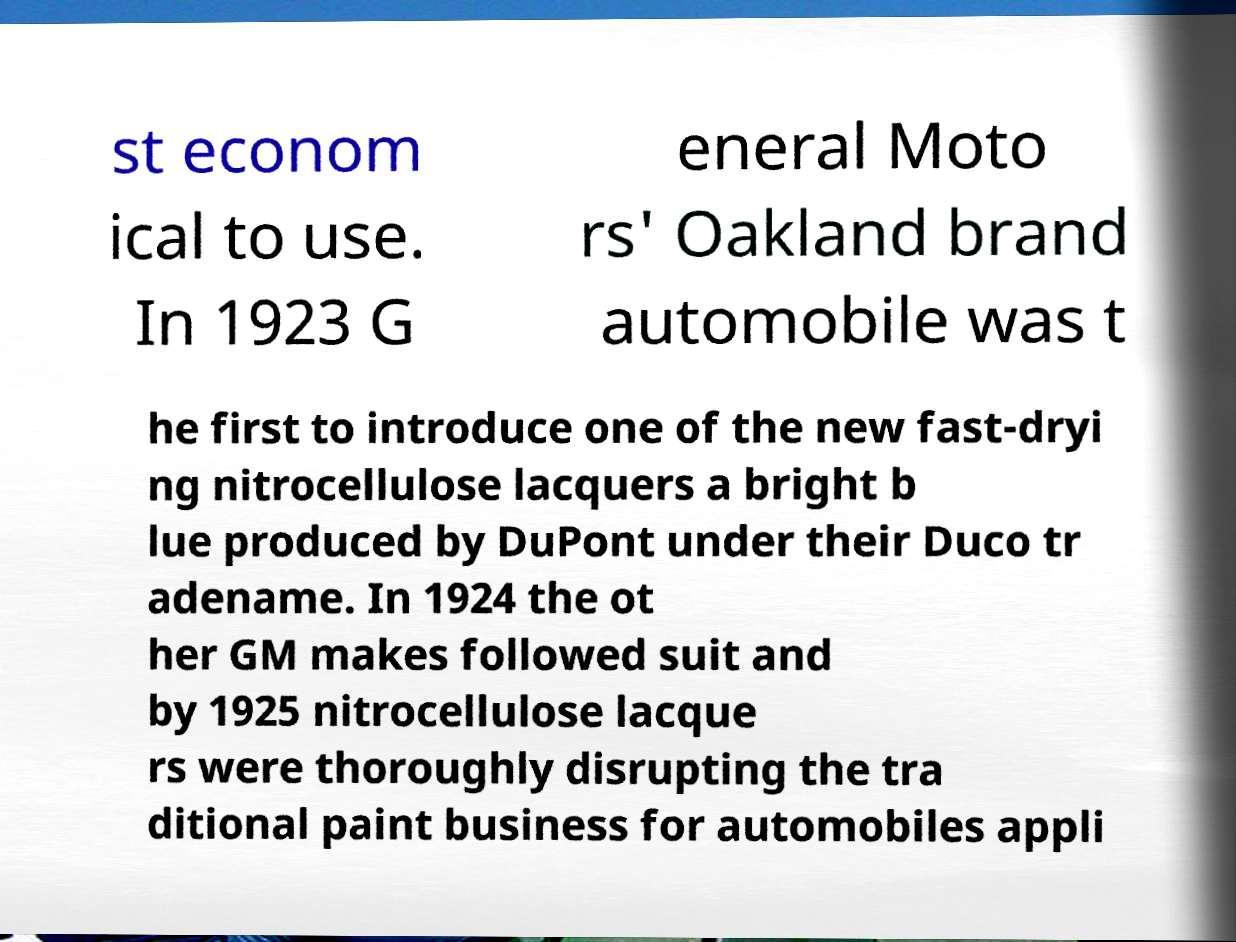I need the written content from this picture converted into text. Can you do that? st econom ical to use. In 1923 G eneral Moto rs' Oakland brand automobile was t he first to introduce one of the new fast-dryi ng nitrocellulose lacquers a bright b lue produced by DuPont under their Duco tr adename. In 1924 the ot her GM makes followed suit and by 1925 nitrocellulose lacque rs were thoroughly disrupting the tra ditional paint business for automobiles appli 